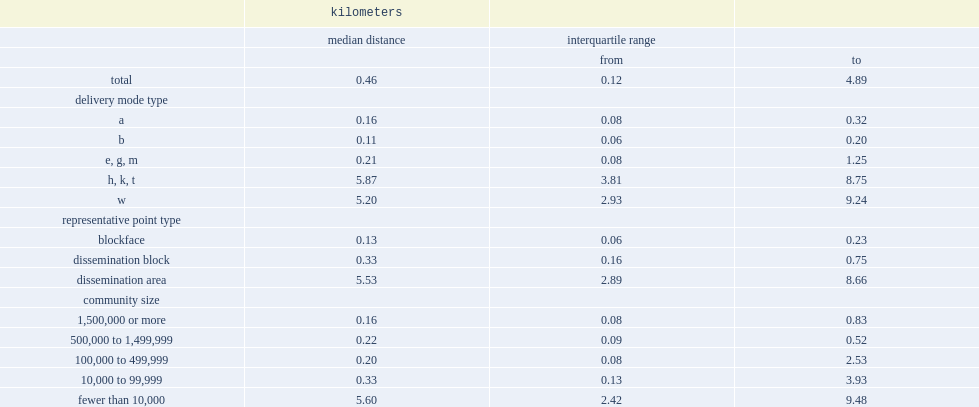Can you give me this table as a dict? {'header': ['', 'kilometers', '', ''], 'rows': [['', 'median distance', 'interquartile range', ''], ['', '', 'from', 'to'], ['total', '0.46', '0.12', '4.89'], ['delivery mode type', '', '', ''], ['a', '0.16', '0.08', '0.32'], ['b', '0.11', '0.06', '0.20'], ['e, g, m', '0.21', '0.08', '1.25'], ['h, k, t', '5.87', '3.81', '8.75'], ['w', '5.20', '2.93', '9.24'], ['representative point type', '', '', ''], ['blockface', '0.13', '0.06', '0.23'], ['dissemination block', '0.33', '0.16', '0.75'], ['dissemination area', '5.53', '2.89', '8.66'], ['community size', '', '', ''], ['1,500,000 or more', '0.16', '0.08', '0.83'], ['500,000 to 1,499,999', '0.22', '0.09', '0.52'], ['100,000 to 499,999', '0.20', '0.08', '2.53'], ['10,000 to 99,999', '0.33', '0.13', '3.93'], ['fewer than 10,000', '5.60', '2.42', '9.48']]} Which had greater accuracy,urban postal codes or rural and mixed postal codes? E, g, m. Which had the best accuracy? E, g, m. What was the number of median distance (km)of e, g, m (urban business and institutional)? 0.21. List the delivery mode type with the greatest median distances. H, k, t. What was the median distance for blockfaces(km)? 0.13. List the community size with the longest median distance. Fewer than 10,000. 